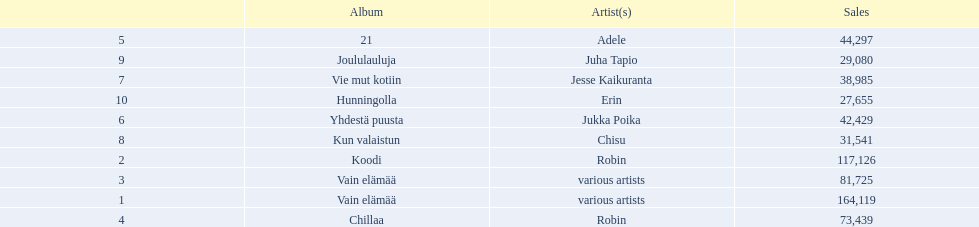What are all the album titles? Vain elämää, Koodi, Vain elämää, Chillaa, 21, Yhdestä puusta, Vie mut kotiin, Kun valaistun, Joululauluja, Hunningolla. Which artists were on the albums? Various artists, robin, various artists, robin, adele, jukka poika, jesse kaikuranta, chisu, juha tapio, erin. Along with chillaa, which other album featured robin? Koodi. 